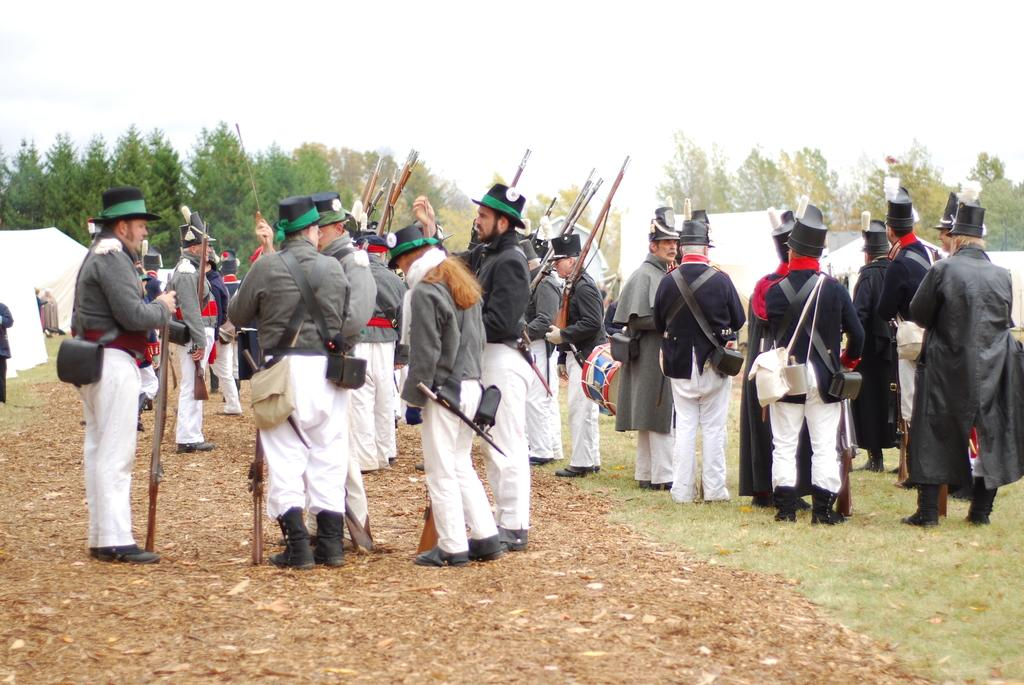How many people are in the image? There is a group of people in the image. What are the people doing in the image? The people are standing together. What are the people wearing in the image? The people are wearing bags. What are the people holding in the image? The people are holding objects. What type of structures can be seen in the image? There are tents in the image. What type of vegetation is present in the image? There are trees in the image. How many mice can be seen running around the people in the image? There are no mice present in the image; it only features a group of people, tents, and trees. 